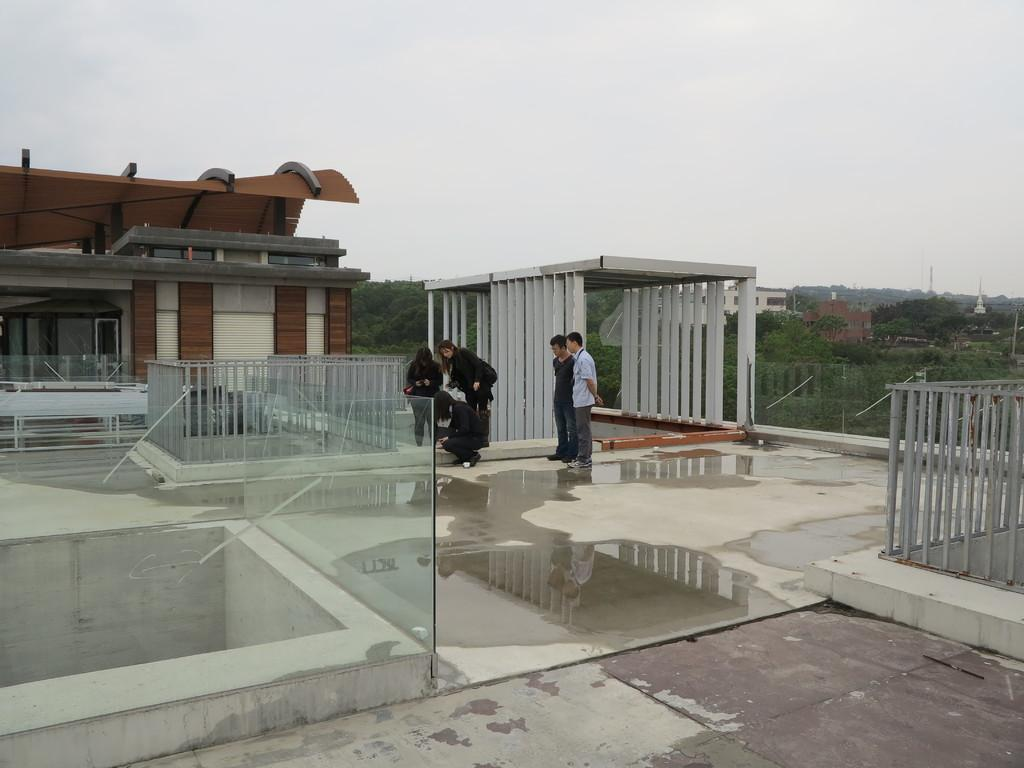What are the people in the image doing? The group of people is standing on the terrace of a building. What can be seen in the image besides the people? Iron rods, water, buildings, trees, and the sky are visible in the image. What is the background of the image like? The background of the image includes buildings, trees, and the sky. What month is it in the image? The month cannot be determined from the image, as there is no information about the time of year. What type of muscle can be seen in the image? There are no muscles visible in the image; it features a group of people standing on a terrace, iron rods, water, buildings, trees, and the sky. 